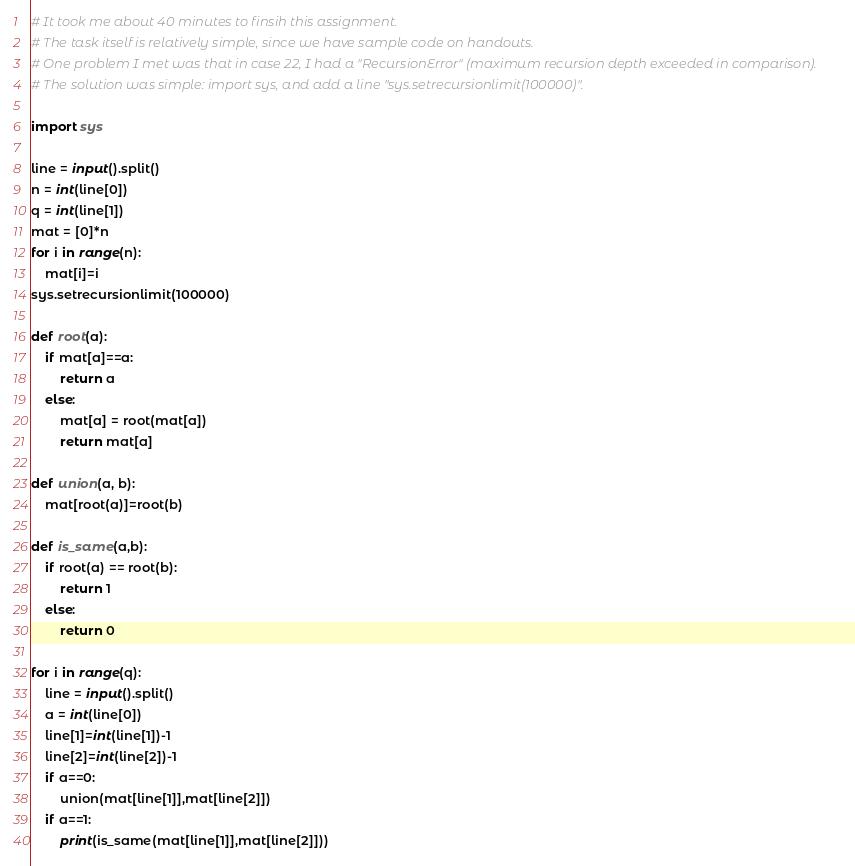<code> <loc_0><loc_0><loc_500><loc_500><_Python_># It took me about 40 minutes to finsih this assignment.
# The task itself is relatively simple, since we have sample code on handouts.
# One problem I met was that in case 22, I had a "RecursionError" (maximum recursion depth exceeded in comparison).
# The solution was simple: import sys, and add a line "sys.setrecursionlimit(100000)".

import sys

line = input().split()
n = int(line[0])
q = int(line[1])
mat = [0]*n
for i in range(n):
	mat[i]=i
sys.setrecursionlimit(100000)

def root(a):
	if mat[a]==a:
		return a
	else:
		mat[a] = root(mat[a])
		return mat[a]

def union(a, b):
	mat[root(a)]=root(b)

def is_same(a,b):
	if root(a) == root(b):
		return 1
	else:
		return 0

for i in range(q):
	line = input().split()
	a = int(line[0])
	line[1]=int(line[1])-1
	line[2]=int(line[2])-1
	if a==0:
		union(mat[line[1]],mat[line[2]])
	if a==1:
		print(is_same(mat[line[1]],mat[line[2]]))</code> 